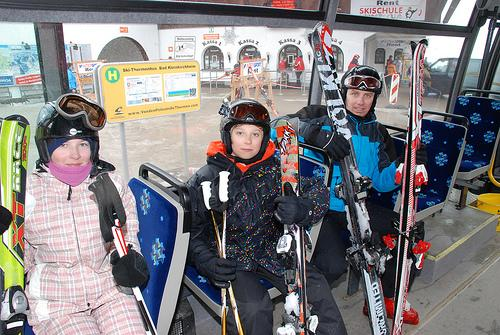Identify the primary activity occurring in the image. A group of skiers riding a bus to the slopes. Characterize the environment outside the bus. A busy ski resort area with a yellow sign, ski lift, and staging area for skiers. List all the objects and people mentioned in the image that are related to skiing. Skiers, ski poles, green skiis, two pairs of other skis, black helmets, orange goggles, red goggles, and a staging area for skiers. Analyze the scene inside the bus in terms of object interactions. People are holding ski equipment, sitting on blue seats, some wearing helmets with goggles, while there's a yellow line on the floor and a center for paying fares. What is the overall sentiment conveyed by the image? The image conveys an exciting and busy atmosphere as people are preparing for a day of skiing at the resort. Mention the different types of headgear worn by people in the image. Black helmets, orange goggles, red goggles, and an orange hood are being worn in the image. Count the number of people wearing helmets and provide a brief description of their helmets. Two people are wearing helmets: one has a black helmet with red goggles and the other has a black helmet with orange goggles. What colors are the lady's outfit, who is wearing a purple scarf? The lady is wearing a black coat, purple scarf, and pink plaid suit. Are there any pieces of ski equipment being held by people in the image? Yes, there are ski poles, green skiis, and two pairs of other skis being held by individuals. Describe an uncommon feature of the blue bus seat. The blue bus seat has a floral pattern on it. Which statement accurately describes the woman's ski poles? A. She is holding them. B. She left them on the bus seat. C. They are stuck in the snow. A. She is holding them. Is the lady holding the ski poles wearing goggles as well? No, she is not. Identify the type of headgear worn by the woman in the image. A black helmet. What can be seen through the window of the bus? A yellow sign. What color is the scarf that the girl is wearing? Purple. Can you describe the staging area for the skiers? It is a bus that transports people to the resort area. Describe the pattern on the blue bus seat. It has a floral pattern. What types of ski wear are the man and woman wearing? The man is wearing blue ski wear and the woman is wearing a black coat. Does the bus provide a service for transporting skiers? Yes, it does. Is there an empty chair on the ski lift visible in the image? Yes, there is. What type of seat is the woman sitting on? A blue bus seat. Is the lady wearing the black helmet entertained, worried, or indifferent? Indifferent. In the image, does the woman have her ski poles and her green skis in her hands? Yes, she does. Which of these best describes the scene? A. Skiers taking a break at a coffee shop. B. Skiers on a bus heading to the slopes. C. People sunbathing at the beach. B. Skiers on a bus heading to the slopes. Describe the color of the jacket the female skier is wearing. She is wearing a black jacket. What are the people on the bus doing? They are going to the slopes for skiing. What color are the goggles on the black helmet? The goggles are red. 